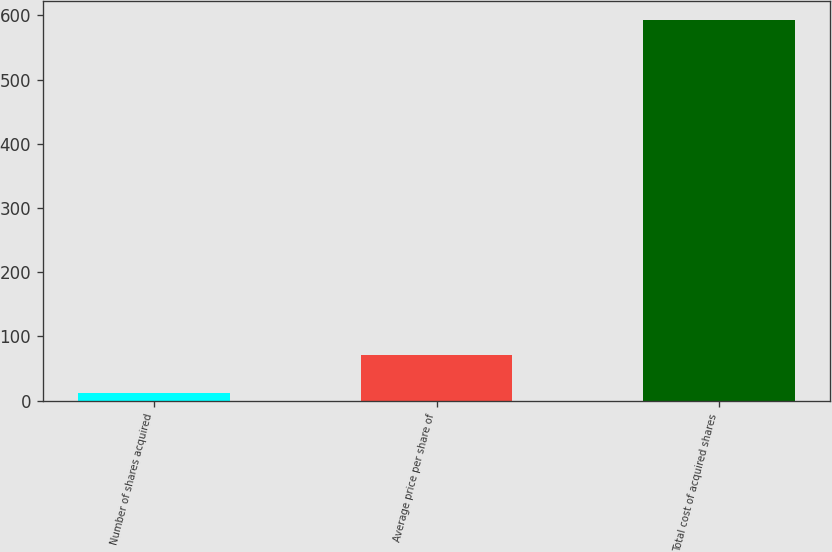Convert chart. <chart><loc_0><loc_0><loc_500><loc_500><bar_chart><fcel>Number of shares acquired<fcel>Average price per share of<fcel>Total cost of acquired shares<nl><fcel>12.3<fcel>70.39<fcel>593.2<nl></chart> 